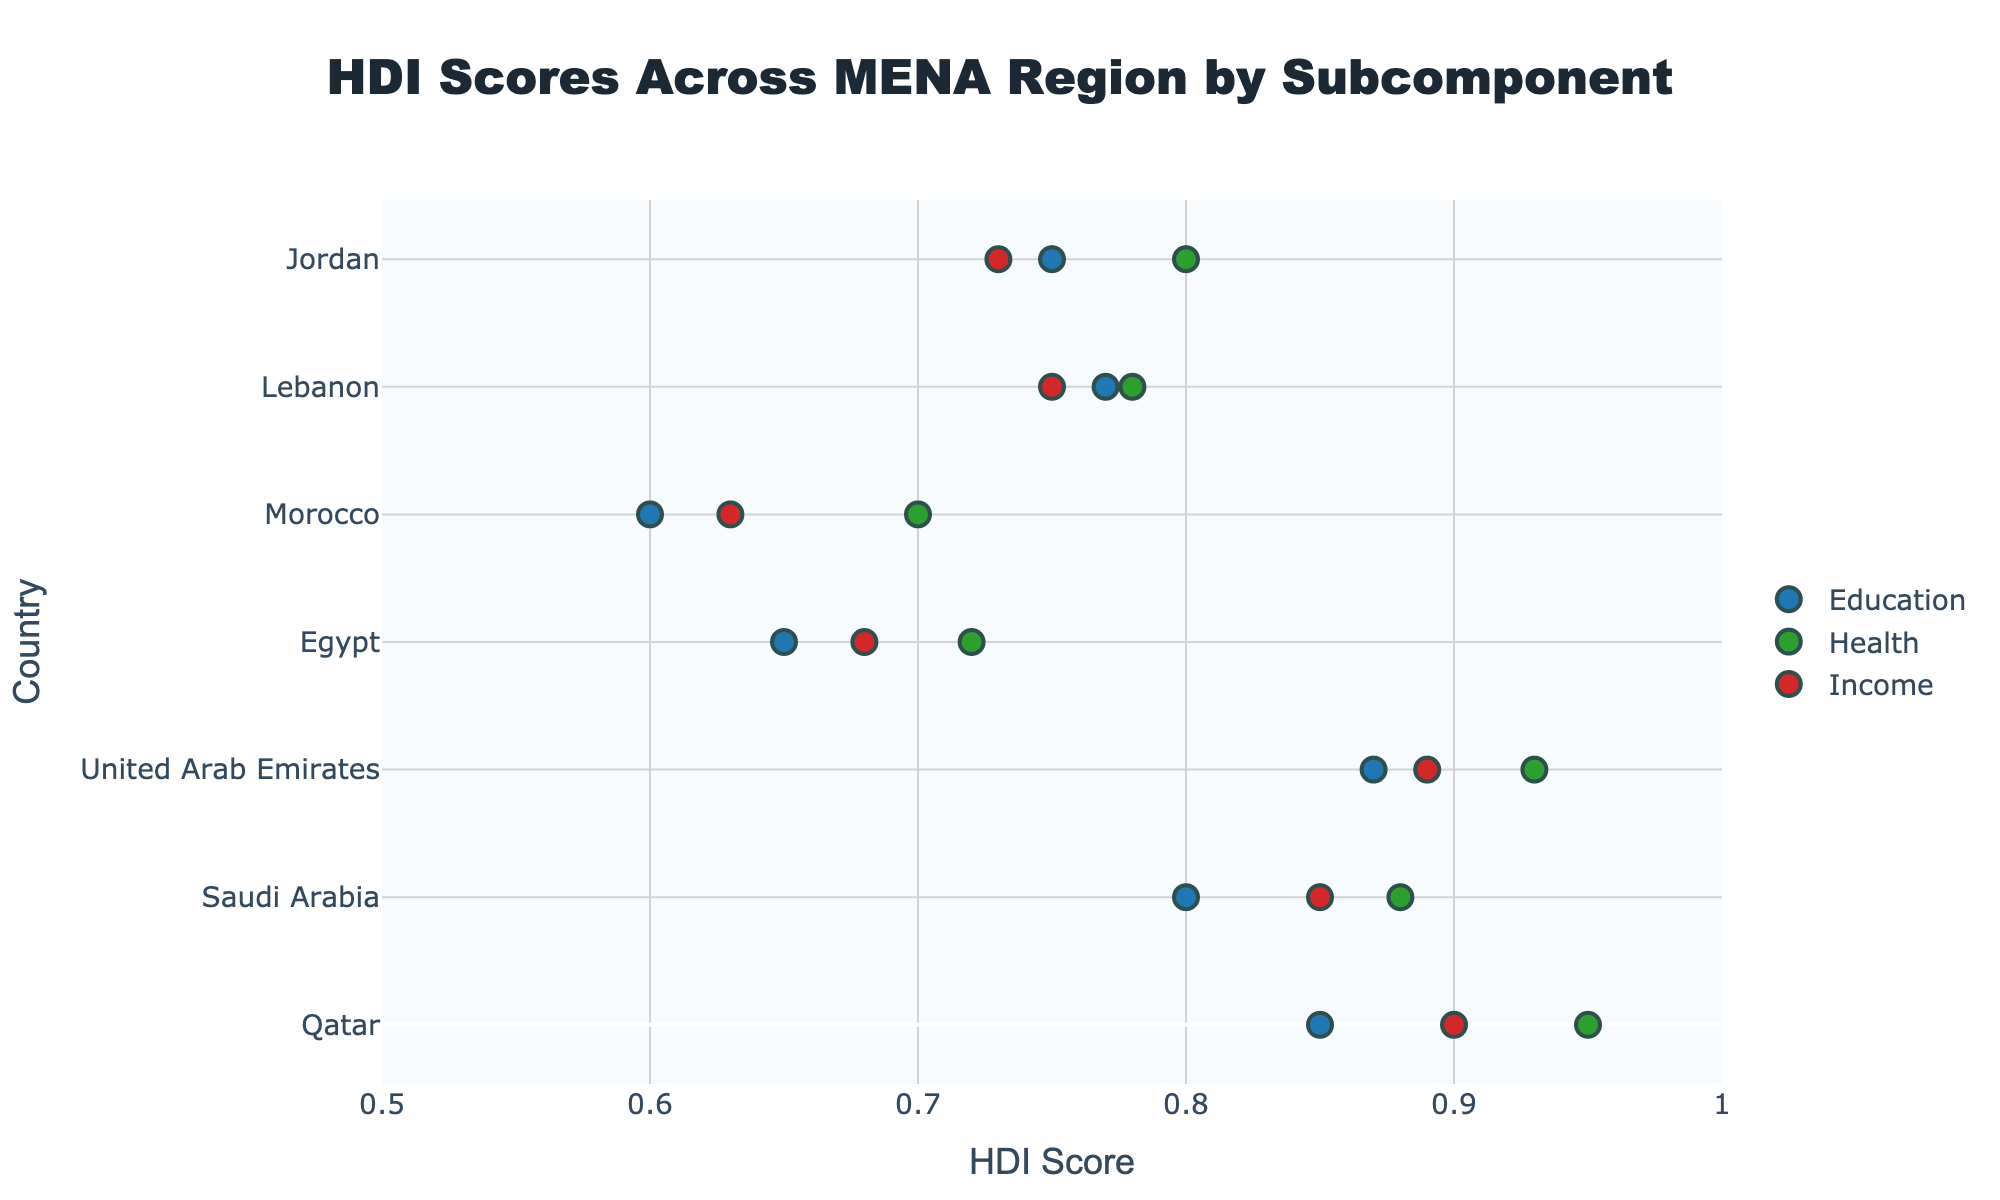What is the title of the plot? The title of the plot is typically located at the top and provides a brief idea about the content. In this case, it's clearly stated at the top-center.
Answer: HDI Scores Across MENA Region by Subcomponent What are the three subcomponents depicted in the plot? By observing the legend on the right side of the plot, we can see the names and color codes of the subcomponents.
Answer: Education, Health, Income Which country has the highest score in the Health subcomponent? By looking at the green dots which represent Health scores, the highest position on the x-axis is held by one of these.
Answer: Qatar What is the range of HDI scores represented on the x-axis? The range is indicated by the x-axis labels. The minimum and maximum values these labels cover form the range.
Answer: 0.5 to 1 Which country has the lowest score in the Education subcomponent? By examining the blue dots aligned with each country for the Education subcomponent and finding the one positioned farthest to the left.
Answer: Morocco What is the average Health score of Qatar, Saudi Arabia, and United Arab Emirates? Sum the Health scores for these three countries and divide by three: (0.95 + 0.88 + 0.93) / 3 = 2.76 / 3 = 0.92
Answer: 0.92 Which country's Income score is closest to its Education score? Compare the difference between the Education and Income scores for each country and identify the smallest difference.
Answer: Lebanon Which country shows the most significant difference between its Health and Income scores? Calculate the absolute difference between Health and Income scores for each country and find the maximum difference.
Answer: Jordan How many data points are displayed for each country? Each country is represented by one dot for each subcomponent. Since there are three subcomponents, each country will have three dots.
Answer: 3 Between Jordan and Egypt, which country has a higher Education score? Compare the Education scores (blue dots) for Jordan and Egypt by checking the position on the x-axis.
Answer: Jordan 